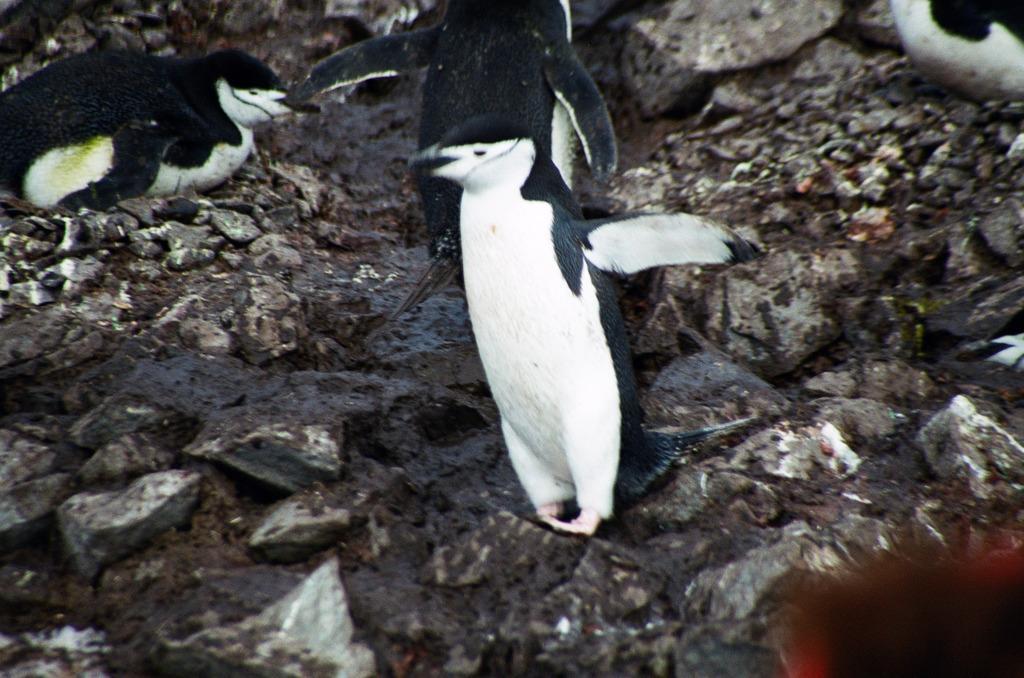Please provide a concise description of this image. In this image we can see penguins on this surface. 